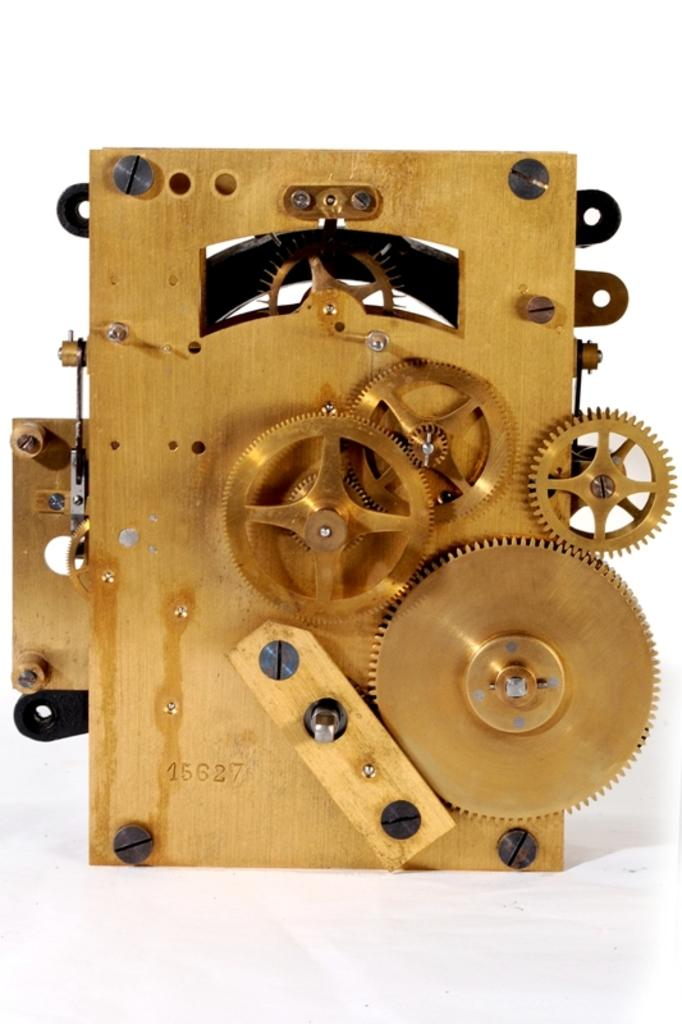What is the main subject of the image? There is a machine in the image. Can you tell me how many cows are standing next to the machine in the image? There is no cow present in the image; it only features a machine. What type of thrill can be experienced while operating the machine in the image? The image does not provide any information about the function or purpose of the machine, so it is impossible to determine if any thrill can be experienced while operating it. 